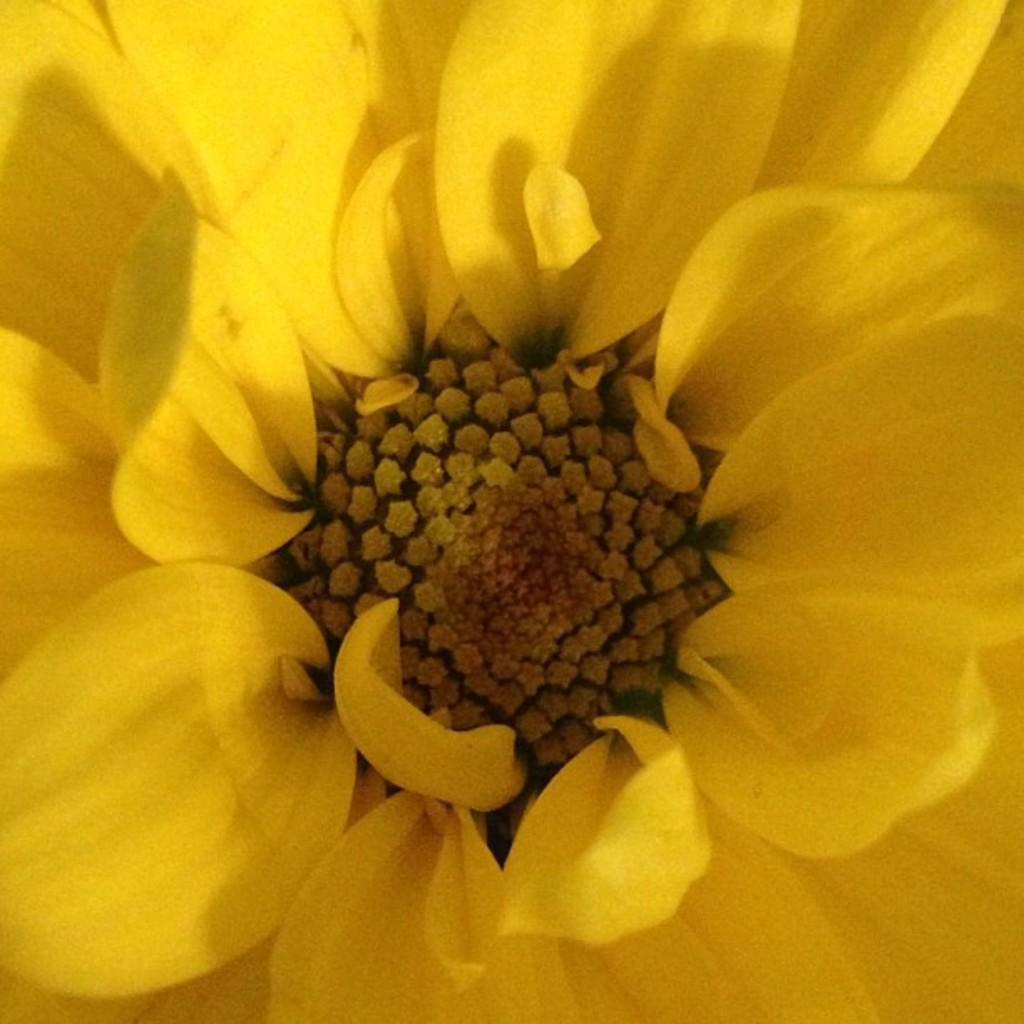What type of flower can be seen in the image? There is a yellow color flower in the image. What type of agreement was reached between the bushes in the image? There are no bushes present in the image, and therefore no agreement can be reached between them. What part of the body is visible in the image? The image only subject of the image is a flower, and no part of a body is visible. 